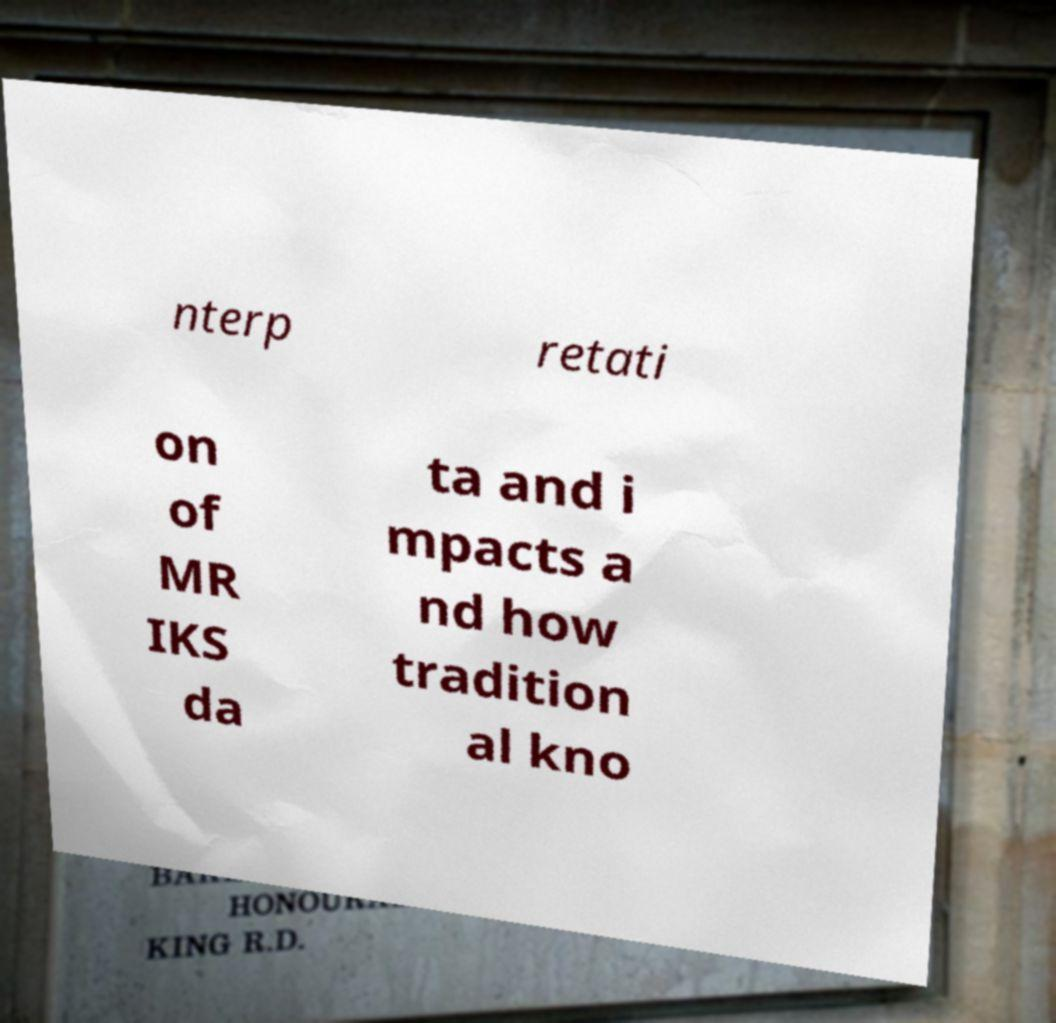Please identify and transcribe the text found in this image. nterp retati on of MR IKS da ta and i mpacts a nd how tradition al kno 